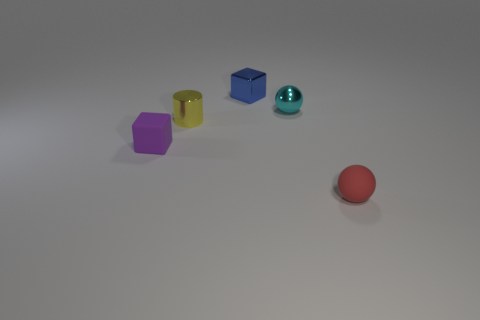Subtract all red spheres. How many spheres are left? 1 Add 3 metallic spheres. How many objects exist? 8 Subtract all cylinders. How many objects are left? 4 Subtract all blue spheres. Subtract all blue blocks. How many spheres are left? 2 Subtract all green metallic cubes. Subtract all small metal balls. How many objects are left? 4 Add 1 cyan balls. How many cyan balls are left? 2 Add 4 large blue matte spheres. How many large blue matte spheres exist? 4 Subtract 0 brown cylinders. How many objects are left? 5 